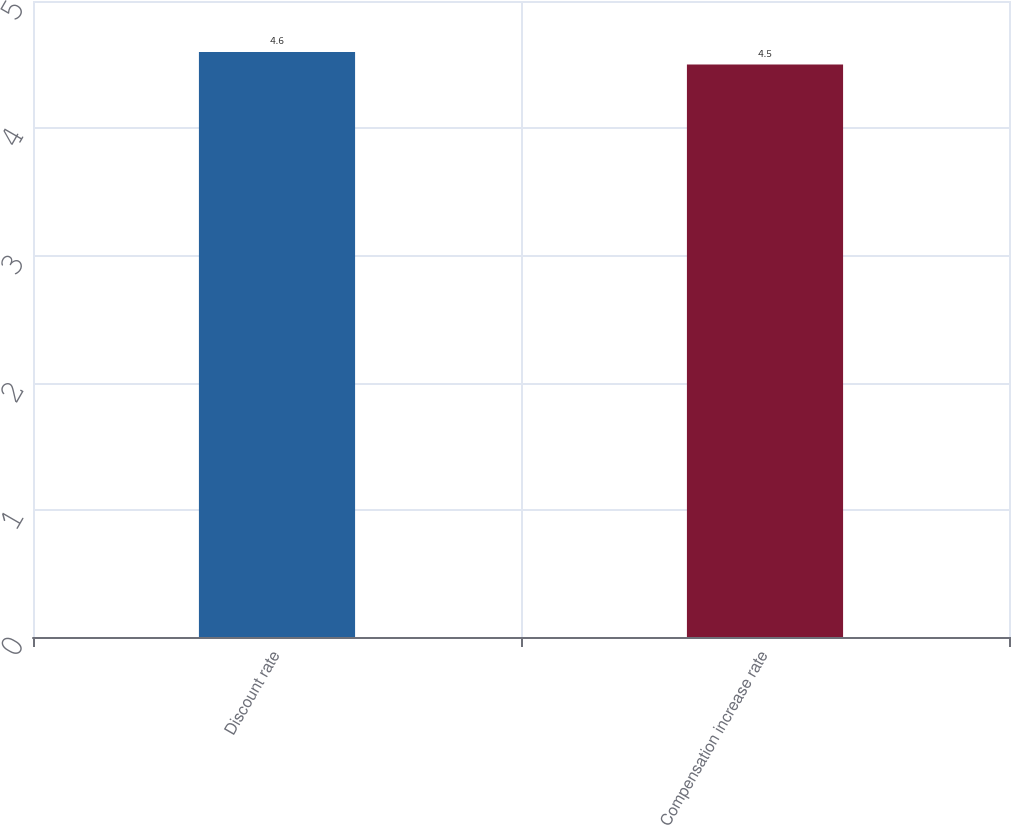Convert chart to OTSL. <chart><loc_0><loc_0><loc_500><loc_500><bar_chart><fcel>Discount rate<fcel>Compensation increase rate<nl><fcel>4.6<fcel>4.5<nl></chart> 